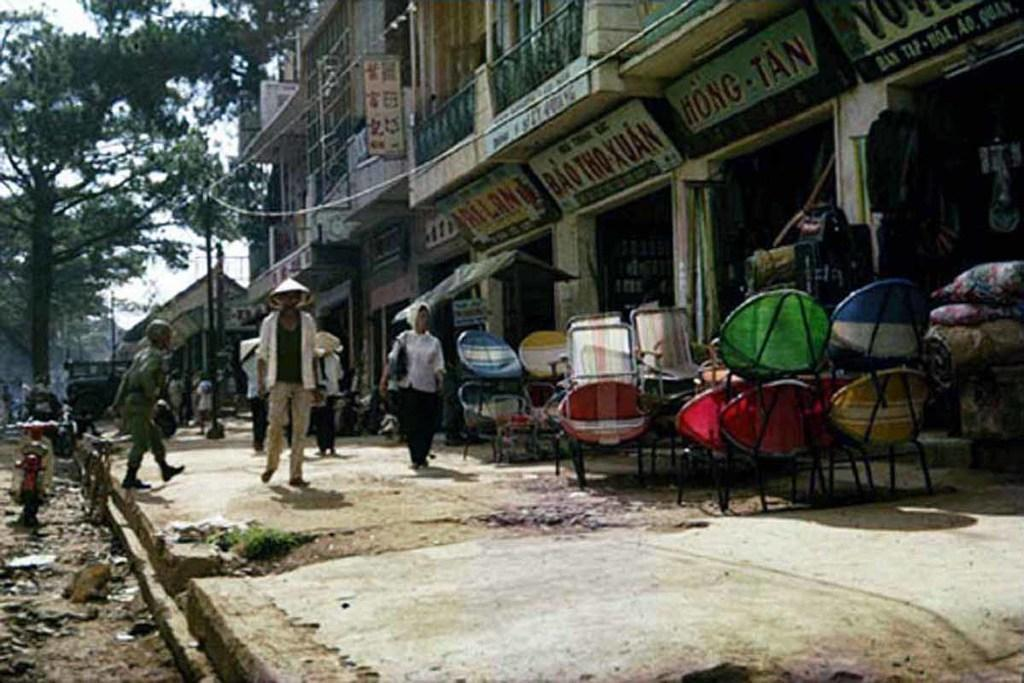How many people are present in the image? There are people in the image, but the exact number is not specified. What are some of the people doing in the image? Some people are walking in the image. What type of furniture can be seen in the image? There are chairs in the image. What other objects are present in the image? There are objects in the image, but their specific nature is not mentioned. What type of signage is visible in the image? There are hoardings in the image. What type of structures are visible in the image? There are buildings in the image. What type of barrier is present in the image? There are railings in the image. What type of vegetation is visible in the image? There are trees in the image. What can be seen in the background of the image? The sky is visible in the background of the image. How many baby threads can be seen in the image? There are no baby threads present in the image. 